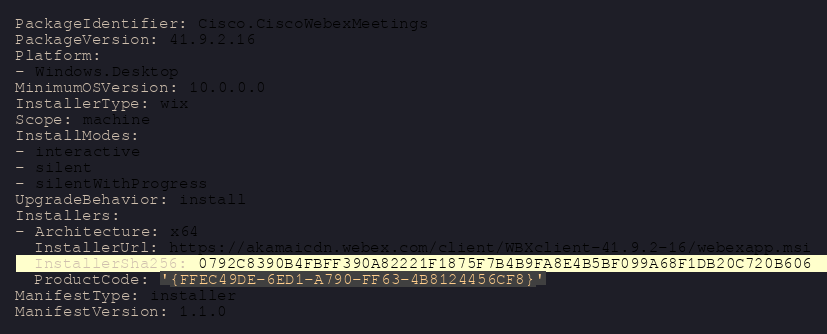<code> <loc_0><loc_0><loc_500><loc_500><_YAML_>
PackageIdentifier: Cisco.CiscoWebexMeetings
PackageVersion: 41.9.2.16
Platform:
- Windows.Desktop
MinimumOSVersion: 10.0.0.0
InstallerType: wix
Scope: machine
InstallModes:
- interactive
- silent
- silentWithProgress
UpgradeBehavior: install
Installers:
- Architecture: x64
  InstallerUrl: https://akamaicdn.webex.com/client/WBXclient-41.9.2-16/webexapp.msi
  InstallerSha256: 0792C8390B4FBFF390A82221F1875F7B4B9FA8E4B5BF099A68F1DB20C720B606
  ProductCode: '{FFEC49DE-6ED1-A790-FF63-4B8124456CF8}'
ManifestType: installer
ManifestVersion: 1.1.0
</code> 